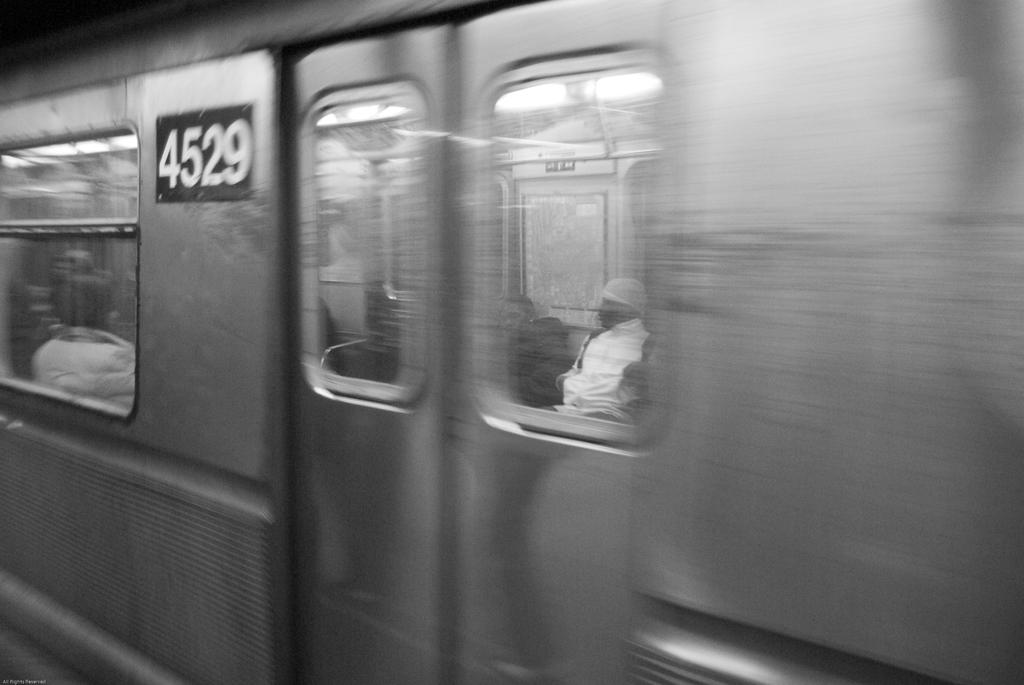<image>
Give a short and clear explanation of the subsequent image. a black and white image of a train car number 4529 